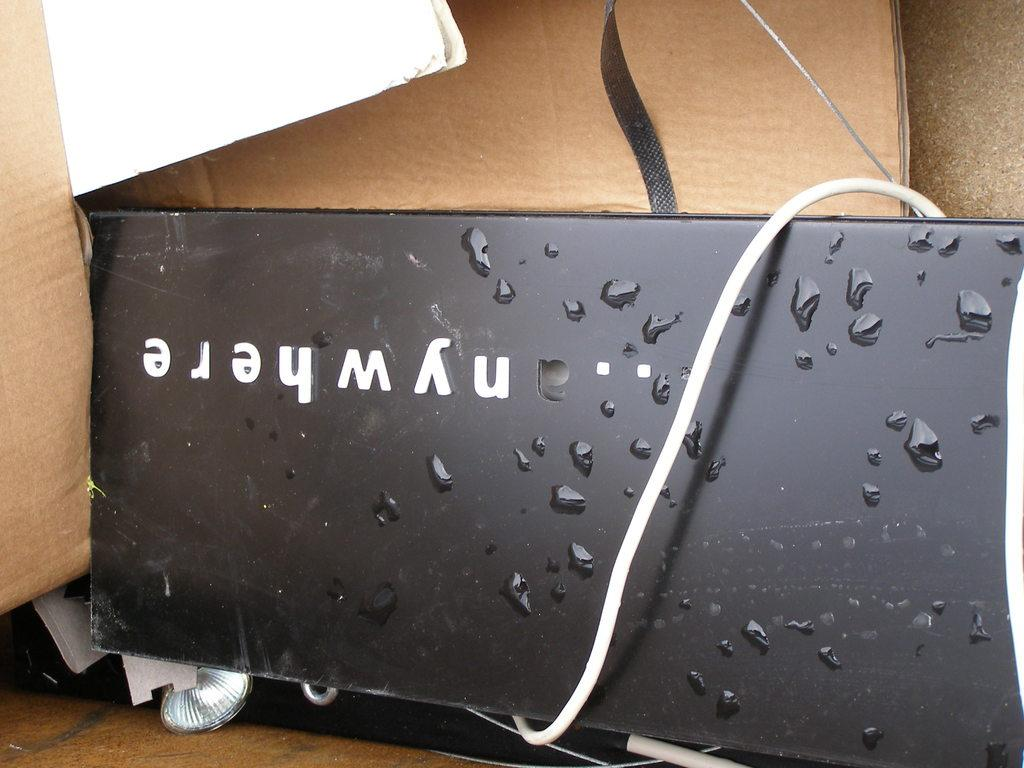<image>
Provide a brief description of the given image. A box with a black metal device by Nywhere with a white cord around it. 